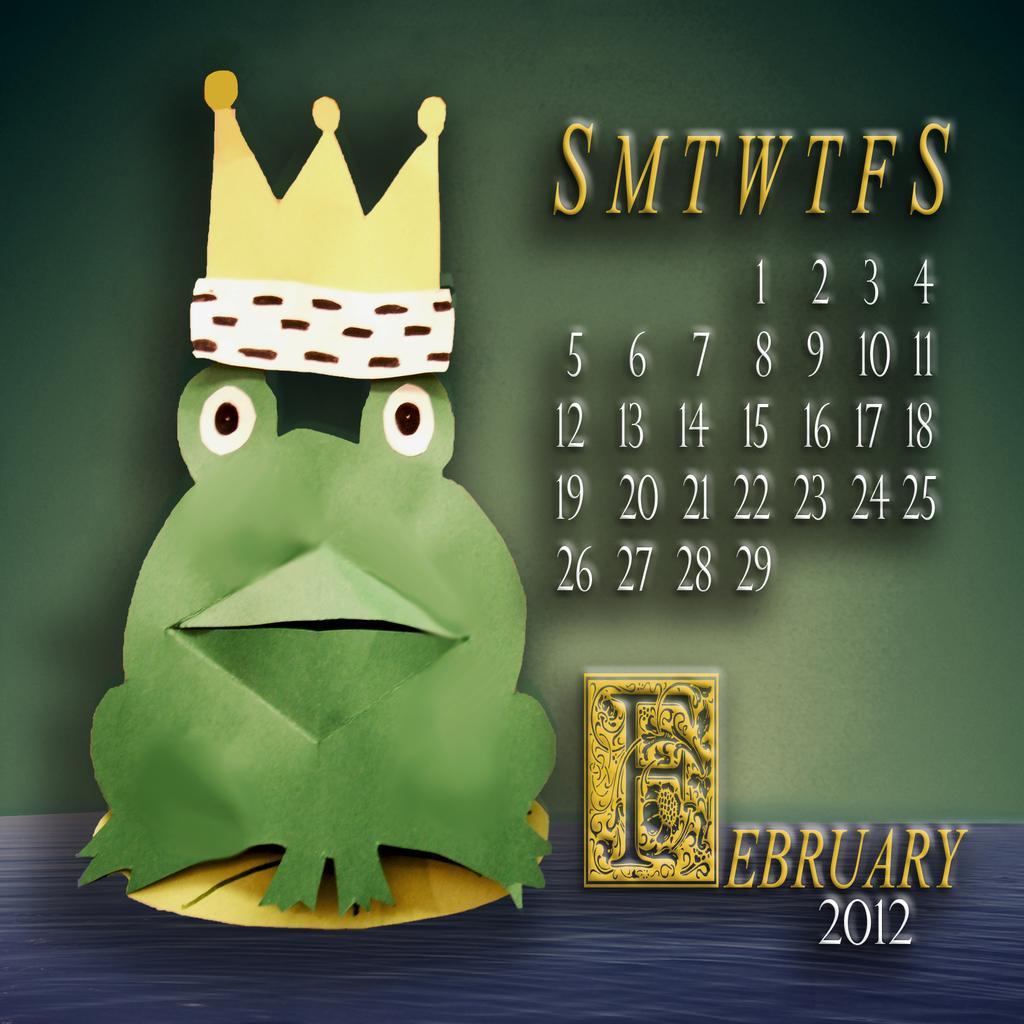Describe this image in one or two sentences. In the image I can see a calendar and a cartoon image of a frog and a crown. 